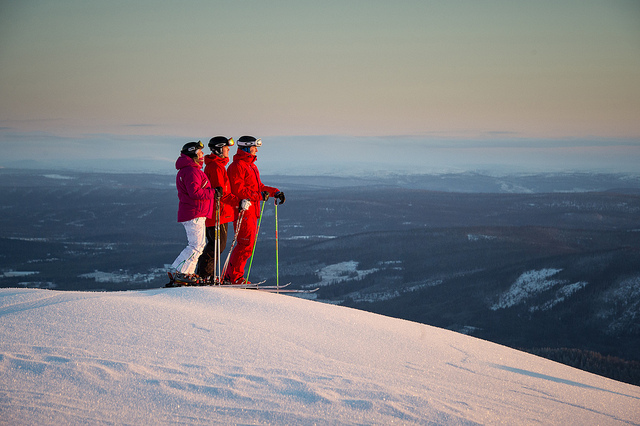How many people are there? There are three people, standing side-by-side on snow-covered terrain, likely at the top of a ski slope. Each person is dressed in warm ski gear, and it appears that they are skiers or snowboarders taking in the views before descending. 